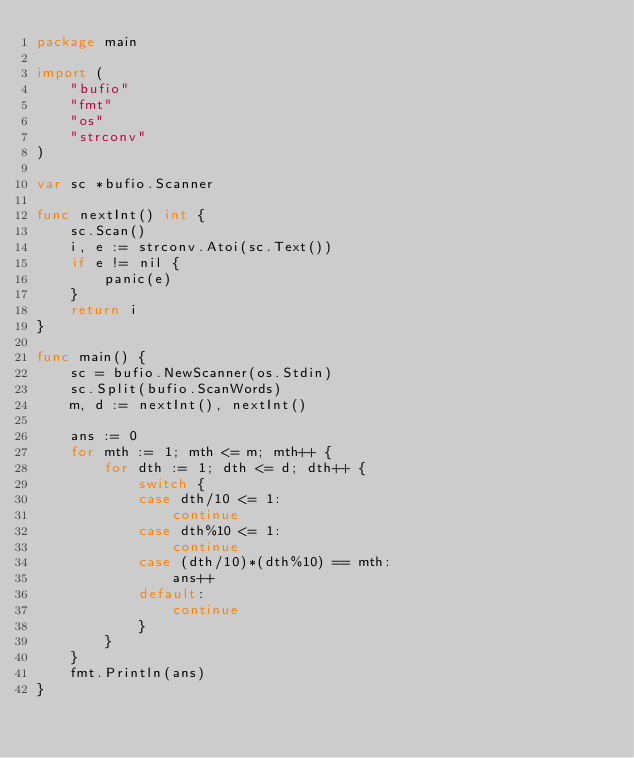<code> <loc_0><loc_0><loc_500><loc_500><_Go_>package main

import (
	"bufio"
	"fmt"
	"os"
	"strconv"
)

var sc *bufio.Scanner

func nextInt() int {
	sc.Scan()
	i, e := strconv.Atoi(sc.Text())
	if e != nil {
		panic(e)
	}
	return i
}

func main() {
	sc = bufio.NewScanner(os.Stdin)
	sc.Split(bufio.ScanWords)
	m, d := nextInt(), nextInt()

	ans := 0
	for mth := 1; mth <= m; mth++ {
		for dth := 1; dth <= d; dth++ {
			switch {
			case dth/10 <= 1:
				continue
			case dth%10 <= 1:
				continue
			case (dth/10)*(dth%10) == mth:
				ans++
			default:
				continue
			}
		}
	}
	fmt.Println(ans)
}
</code> 